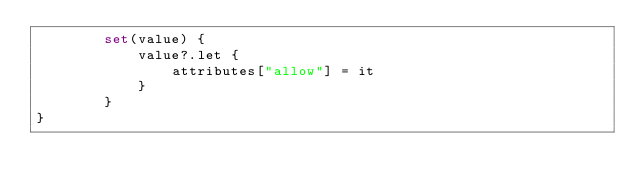<code> <loc_0><loc_0><loc_500><loc_500><_Kotlin_>		set(value) {
			value?.let {
				attributes["allow"] = it
			}
		}
}	
</code> 